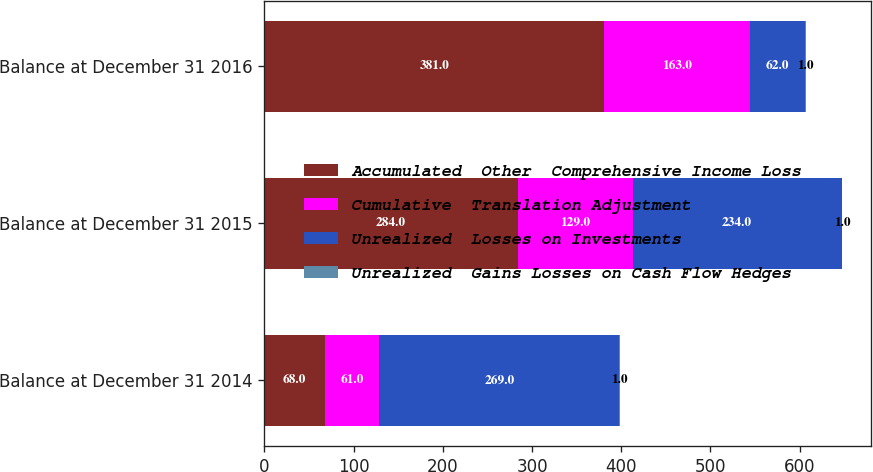Convert chart to OTSL. <chart><loc_0><loc_0><loc_500><loc_500><stacked_bar_chart><ecel><fcel>Balance at December 31 2014<fcel>Balance at December 31 2015<fcel>Balance at December 31 2016<nl><fcel>Accumulated  Other  Comprehensive Income Loss<fcel>68<fcel>284<fcel>381<nl><fcel>Cumulative  Translation Adjustment<fcel>61<fcel>129<fcel>163<nl><fcel>Unrealized  Losses on Investments<fcel>269<fcel>234<fcel>62<nl><fcel>Unrealized  Gains Losses on Cash Flow Hedges<fcel>1<fcel>1<fcel>1<nl></chart> 